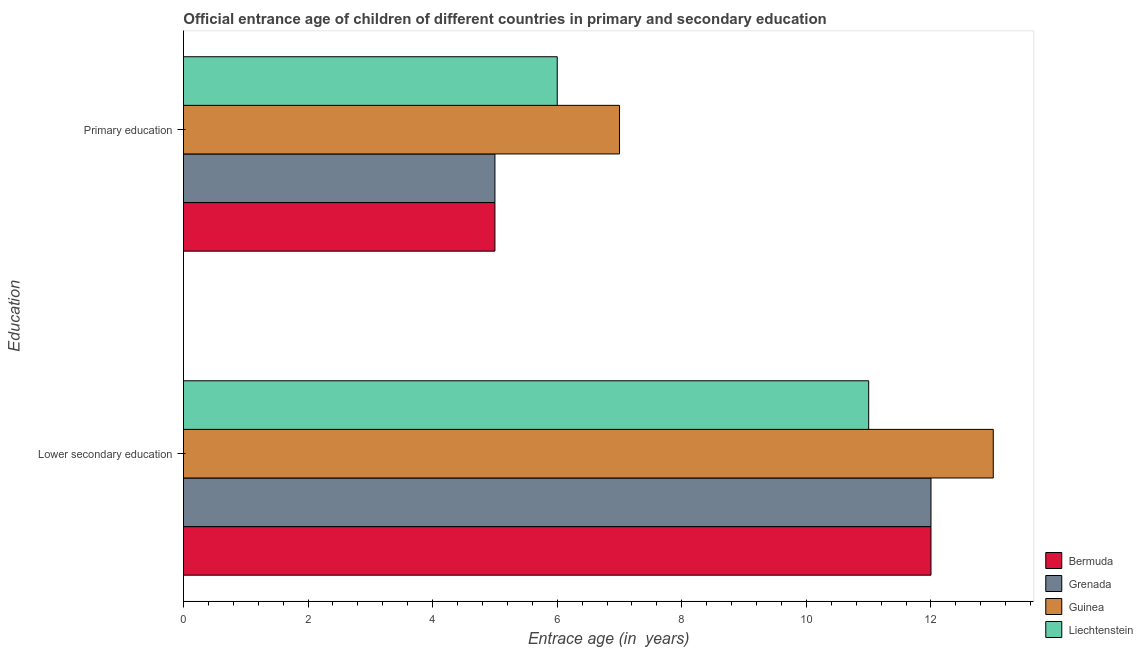How many groups of bars are there?
Your response must be concise. 2. Are the number of bars on each tick of the Y-axis equal?
Make the answer very short. Yes. How many bars are there on the 1st tick from the top?
Your answer should be very brief. 4. How many bars are there on the 1st tick from the bottom?
Offer a terse response. 4. What is the label of the 2nd group of bars from the top?
Offer a very short reply. Lower secondary education. What is the entrance age of children in lower secondary education in Grenada?
Provide a short and direct response. 12. Across all countries, what is the maximum entrance age of children in lower secondary education?
Offer a terse response. 13. Across all countries, what is the minimum entrance age of children in lower secondary education?
Provide a succinct answer. 11. In which country was the entrance age of chiildren in primary education maximum?
Offer a very short reply. Guinea. In which country was the entrance age of chiildren in primary education minimum?
Your response must be concise. Bermuda. What is the total entrance age of chiildren in primary education in the graph?
Provide a short and direct response. 23. What is the difference between the entrance age of children in lower secondary education in Guinea and that in Grenada?
Provide a short and direct response. 1. What is the difference between the entrance age of chiildren in primary education in Grenada and the entrance age of children in lower secondary education in Bermuda?
Your answer should be compact. -7. What is the difference between the entrance age of chiildren in primary education and entrance age of children in lower secondary education in Bermuda?
Make the answer very short. -7. In how many countries, is the entrance age of children in lower secondary education greater than 9.6 years?
Keep it short and to the point. 4. What is the ratio of the entrance age of children in lower secondary education in Liechtenstein to that in Grenada?
Your answer should be compact. 0.92. Is the entrance age of chiildren in primary education in Bermuda less than that in Guinea?
Your answer should be very brief. Yes. In how many countries, is the entrance age of children in lower secondary education greater than the average entrance age of children in lower secondary education taken over all countries?
Your response must be concise. 1. What does the 4th bar from the top in Primary education represents?
Offer a terse response. Bermuda. What does the 1st bar from the bottom in Primary education represents?
Your response must be concise. Bermuda. How many countries are there in the graph?
Give a very brief answer. 4. What is the difference between two consecutive major ticks on the X-axis?
Your answer should be very brief. 2. Does the graph contain grids?
Give a very brief answer. No. How many legend labels are there?
Your answer should be very brief. 4. How are the legend labels stacked?
Ensure brevity in your answer.  Vertical. What is the title of the graph?
Give a very brief answer. Official entrance age of children of different countries in primary and secondary education. Does "Sint Maarten (Dutch part)" appear as one of the legend labels in the graph?
Your answer should be compact. No. What is the label or title of the X-axis?
Make the answer very short. Entrace age (in  years). What is the label or title of the Y-axis?
Make the answer very short. Education. What is the Entrace age (in  years) of Grenada in Lower secondary education?
Give a very brief answer. 12. What is the Entrace age (in  years) of Guinea in Lower secondary education?
Offer a terse response. 13. What is the Entrace age (in  years) of Liechtenstein in Lower secondary education?
Ensure brevity in your answer.  11. What is the Entrace age (in  years) in Bermuda in Primary education?
Your answer should be very brief. 5. What is the Entrace age (in  years) of Grenada in Primary education?
Your answer should be compact. 5. Across all Education, what is the maximum Entrace age (in  years) of Grenada?
Ensure brevity in your answer.  12. Across all Education, what is the maximum Entrace age (in  years) in Liechtenstein?
Make the answer very short. 11. Across all Education, what is the minimum Entrace age (in  years) of Guinea?
Offer a terse response. 7. What is the total Entrace age (in  years) of Bermuda in the graph?
Give a very brief answer. 17. What is the total Entrace age (in  years) in Guinea in the graph?
Keep it short and to the point. 20. What is the difference between the Entrace age (in  years) of Bermuda in Lower secondary education and the Entrace age (in  years) of Liechtenstein in Primary education?
Give a very brief answer. 6. What is the difference between the Entrace age (in  years) in Guinea in Lower secondary education and the Entrace age (in  years) in Liechtenstein in Primary education?
Ensure brevity in your answer.  7. What is the average Entrace age (in  years) in Grenada per Education?
Offer a terse response. 8.5. What is the difference between the Entrace age (in  years) of Guinea and Entrace age (in  years) of Liechtenstein in Lower secondary education?
Your answer should be compact. 2. What is the difference between the Entrace age (in  years) in Bermuda and Entrace age (in  years) in Liechtenstein in Primary education?
Provide a succinct answer. -1. What is the difference between the Entrace age (in  years) in Grenada and Entrace age (in  years) in Liechtenstein in Primary education?
Your answer should be compact. -1. What is the ratio of the Entrace age (in  years) of Guinea in Lower secondary education to that in Primary education?
Your answer should be very brief. 1.86. What is the ratio of the Entrace age (in  years) in Liechtenstein in Lower secondary education to that in Primary education?
Make the answer very short. 1.83. What is the difference between the highest and the second highest Entrace age (in  years) of Guinea?
Your answer should be compact. 6. What is the difference between the highest and the lowest Entrace age (in  years) in Guinea?
Keep it short and to the point. 6. What is the difference between the highest and the lowest Entrace age (in  years) in Liechtenstein?
Ensure brevity in your answer.  5. 